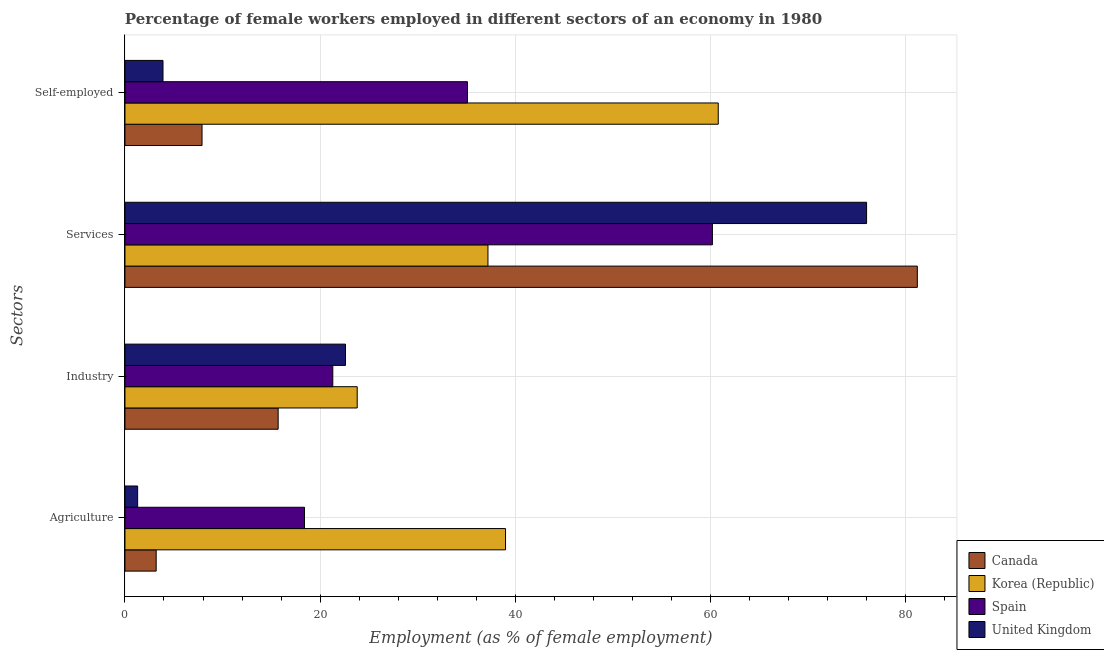How many different coloured bars are there?
Ensure brevity in your answer.  4. Are the number of bars on each tick of the Y-axis equal?
Provide a short and direct response. Yes. How many bars are there on the 3rd tick from the bottom?
Make the answer very short. 4. What is the label of the 3rd group of bars from the top?
Offer a very short reply. Industry. What is the percentage of female workers in industry in Spain?
Ensure brevity in your answer.  21.3. Across all countries, what is the maximum percentage of female workers in agriculture?
Offer a terse response. 39. Across all countries, what is the minimum percentage of female workers in services?
Provide a short and direct response. 37.2. In which country was the percentage of female workers in agriculture maximum?
Keep it short and to the point. Korea (Republic). In which country was the percentage of self employed female workers minimum?
Provide a short and direct response. United Kingdom. What is the total percentage of female workers in services in the graph?
Provide a succinct answer. 254.6. What is the difference between the percentage of female workers in industry in United Kingdom and that in Korea (Republic)?
Keep it short and to the point. -1.2. What is the difference between the percentage of female workers in services in Spain and the percentage of female workers in agriculture in Canada?
Your response must be concise. 57. What is the average percentage of female workers in industry per country?
Offer a very short reply. 20.85. What is the difference between the percentage of self employed female workers and percentage of female workers in industry in Spain?
Your answer should be very brief. 13.8. In how many countries, is the percentage of female workers in industry greater than 44 %?
Your response must be concise. 0. What is the ratio of the percentage of female workers in agriculture in Canada to that in Spain?
Provide a succinct answer. 0.17. Is the difference between the percentage of female workers in services in Korea (Republic) and Canada greater than the difference between the percentage of female workers in industry in Korea (Republic) and Canada?
Give a very brief answer. No. What is the difference between the highest and the second highest percentage of female workers in services?
Provide a short and direct response. 5.2. What is the difference between the highest and the lowest percentage of female workers in agriculture?
Your response must be concise. 37.7. In how many countries, is the percentage of female workers in services greater than the average percentage of female workers in services taken over all countries?
Offer a terse response. 2. What does the 4th bar from the top in Industry represents?
Your answer should be very brief. Canada. What does the 2nd bar from the bottom in Services represents?
Provide a short and direct response. Korea (Republic). How many bars are there?
Give a very brief answer. 16. Does the graph contain any zero values?
Your response must be concise. No. How many legend labels are there?
Provide a short and direct response. 4. What is the title of the graph?
Make the answer very short. Percentage of female workers employed in different sectors of an economy in 1980. What is the label or title of the X-axis?
Your answer should be compact. Employment (as % of female employment). What is the label or title of the Y-axis?
Your answer should be very brief. Sectors. What is the Employment (as % of female employment) of Canada in Agriculture?
Make the answer very short. 3.2. What is the Employment (as % of female employment) in Spain in Agriculture?
Provide a short and direct response. 18.4. What is the Employment (as % of female employment) of United Kingdom in Agriculture?
Ensure brevity in your answer.  1.3. What is the Employment (as % of female employment) in Canada in Industry?
Provide a short and direct response. 15.7. What is the Employment (as % of female employment) in Korea (Republic) in Industry?
Ensure brevity in your answer.  23.8. What is the Employment (as % of female employment) in Spain in Industry?
Keep it short and to the point. 21.3. What is the Employment (as % of female employment) in United Kingdom in Industry?
Make the answer very short. 22.6. What is the Employment (as % of female employment) of Canada in Services?
Give a very brief answer. 81.2. What is the Employment (as % of female employment) in Korea (Republic) in Services?
Provide a short and direct response. 37.2. What is the Employment (as % of female employment) in Spain in Services?
Offer a terse response. 60.2. What is the Employment (as % of female employment) of United Kingdom in Services?
Provide a succinct answer. 76. What is the Employment (as % of female employment) of Canada in Self-employed?
Offer a very short reply. 7.9. What is the Employment (as % of female employment) of Korea (Republic) in Self-employed?
Ensure brevity in your answer.  60.8. What is the Employment (as % of female employment) of Spain in Self-employed?
Make the answer very short. 35.1. What is the Employment (as % of female employment) in United Kingdom in Self-employed?
Provide a succinct answer. 3.9. Across all Sectors, what is the maximum Employment (as % of female employment) in Canada?
Your response must be concise. 81.2. Across all Sectors, what is the maximum Employment (as % of female employment) of Korea (Republic)?
Make the answer very short. 60.8. Across all Sectors, what is the maximum Employment (as % of female employment) of Spain?
Your answer should be very brief. 60.2. Across all Sectors, what is the maximum Employment (as % of female employment) in United Kingdom?
Your answer should be compact. 76. Across all Sectors, what is the minimum Employment (as % of female employment) of Canada?
Offer a terse response. 3.2. Across all Sectors, what is the minimum Employment (as % of female employment) in Korea (Republic)?
Your answer should be very brief. 23.8. Across all Sectors, what is the minimum Employment (as % of female employment) of Spain?
Give a very brief answer. 18.4. Across all Sectors, what is the minimum Employment (as % of female employment) of United Kingdom?
Your response must be concise. 1.3. What is the total Employment (as % of female employment) of Canada in the graph?
Ensure brevity in your answer.  108. What is the total Employment (as % of female employment) of Korea (Republic) in the graph?
Offer a very short reply. 160.8. What is the total Employment (as % of female employment) of Spain in the graph?
Your response must be concise. 135. What is the total Employment (as % of female employment) in United Kingdom in the graph?
Your answer should be compact. 103.8. What is the difference between the Employment (as % of female employment) in Canada in Agriculture and that in Industry?
Ensure brevity in your answer.  -12.5. What is the difference between the Employment (as % of female employment) of Spain in Agriculture and that in Industry?
Provide a succinct answer. -2.9. What is the difference between the Employment (as % of female employment) of United Kingdom in Agriculture and that in Industry?
Give a very brief answer. -21.3. What is the difference between the Employment (as % of female employment) in Canada in Agriculture and that in Services?
Give a very brief answer. -78. What is the difference between the Employment (as % of female employment) in Korea (Republic) in Agriculture and that in Services?
Offer a terse response. 1.8. What is the difference between the Employment (as % of female employment) in Spain in Agriculture and that in Services?
Make the answer very short. -41.8. What is the difference between the Employment (as % of female employment) in United Kingdom in Agriculture and that in Services?
Keep it short and to the point. -74.7. What is the difference between the Employment (as % of female employment) in Canada in Agriculture and that in Self-employed?
Your response must be concise. -4.7. What is the difference between the Employment (as % of female employment) of Korea (Republic) in Agriculture and that in Self-employed?
Your answer should be compact. -21.8. What is the difference between the Employment (as % of female employment) of Spain in Agriculture and that in Self-employed?
Provide a succinct answer. -16.7. What is the difference between the Employment (as % of female employment) in Canada in Industry and that in Services?
Offer a very short reply. -65.5. What is the difference between the Employment (as % of female employment) of Korea (Republic) in Industry and that in Services?
Make the answer very short. -13.4. What is the difference between the Employment (as % of female employment) of Spain in Industry and that in Services?
Provide a short and direct response. -38.9. What is the difference between the Employment (as % of female employment) in United Kingdom in Industry and that in Services?
Provide a succinct answer. -53.4. What is the difference between the Employment (as % of female employment) of Korea (Republic) in Industry and that in Self-employed?
Your response must be concise. -37. What is the difference between the Employment (as % of female employment) of Spain in Industry and that in Self-employed?
Provide a succinct answer. -13.8. What is the difference between the Employment (as % of female employment) of Canada in Services and that in Self-employed?
Your answer should be very brief. 73.3. What is the difference between the Employment (as % of female employment) of Korea (Republic) in Services and that in Self-employed?
Give a very brief answer. -23.6. What is the difference between the Employment (as % of female employment) in Spain in Services and that in Self-employed?
Your response must be concise. 25.1. What is the difference between the Employment (as % of female employment) in United Kingdom in Services and that in Self-employed?
Offer a very short reply. 72.1. What is the difference between the Employment (as % of female employment) of Canada in Agriculture and the Employment (as % of female employment) of Korea (Republic) in Industry?
Offer a very short reply. -20.6. What is the difference between the Employment (as % of female employment) in Canada in Agriculture and the Employment (as % of female employment) in Spain in Industry?
Provide a succinct answer. -18.1. What is the difference between the Employment (as % of female employment) of Canada in Agriculture and the Employment (as % of female employment) of United Kingdom in Industry?
Your response must be concise. -19.4. What is the difference between the Employment (as % of female employment) of Korea (Republic) in Agriculture and the Employment (as % of female employment) of United Kingdom in Industry?
Your response must be concise. 16.4. What is the difference between the Employment (as % of female employment) of Spain in Agriculture and the Employment (as % of female employment) of United Kingdom in Industry?
Make the answer very short. -4.2. What is the difference between the Employment (as % of female employment) in Canada in Agriculture and the Employment (as % of female employment) in Korea (Republic) in Services?
Give a very brief answer. -34. What is the difference between the Employment (as % of female employment) of Canada in Agriculture and the Employment (as % of female employment) of Spain in Services?
Offer a terse response. -57. What is the difference between the Employment (as % of female employment) of Canada in Agriculture and the Employment (as % of female employment) of United Kingdom in Services?
Your answer should be very brief. -72.8. What is the difference between the Employment (as % of female employment) of Korea (Republic) in Agriculture and the Employment (as % of female employment) of Spain in Services?
Ensure brevity in your answer.  -21.2. What is the difference between the Employment (as % of female employment) in Korea (Republic) in Agriculture and the Employment (as % of female employment) in United Kingdom in Services?
Offer a very short reply. -37. What is the difference between the Employment (as % of female employment) in Spain in Agriculture and the Employment (as % of female employment) in United Kingdom in Services?
Offer a terse response. -57.6. What is the difference between the Employment (as % of female employment) of Canada in Agriculture and the Employment (as % of female employment) of Korea (Republic) in Self-employed?
Your answer should be very brief. -57.6. What is the difference between the Employment (as % of female employment) in Canada in Agriculture and the Employment (as % of female employment) in Spain in Self-employed?
Offer a very short reply. -31.9. What is the difference between the Employment (as % of female employment) of Canada in Agriculture and the Employment (as % of female employment) of United Kingdom in Self-employed?
Provide a short and direct response. -0.7. What is the difference between the Employment (as % of female employment) in Korea (Republic) in Agriculture and the Employment (as % of female employment) in United Kingdom in Self-employed?
Your answer should be compact. 35.1. What is the difference between the Employment (as % of female employment) in Spain in Agriculture and the Employment (as % of female employment) in United Kingdom in Self-employed?
Offer a very short reply. 14.5. What is the difference between the Employment (as % of female employment) of Canada in Industry and the Employment (as % of female employment) of Korea (Republic) in Services?
Your answer should be compact. -21.5. What is the difference between the Employment (as % of female employment) of Canada in Industry and the Employment (as % of female employment) of Spain in Services?
Make the answer very short. -44.5. What is the difference between the Employment (as % of female employment) of Canada in Industry and the Employment (as % of female employment) of United Kingdom in Services?
Provide a succinct answer. -60.3. What is the difference between the Employment (as % of female employment) of Korea (Republic) in Industry and the Employment (as % of female employment) of Spain in Services?
Offer a very short reply. -36.4. What is the difference between the Employment (as % of female employment) in Korea (Republic) in Industry and the Employment (as % of female employment) in United Kingdom in Services?
Offer a terse response. -52.2. What is the difference between the Employment (as % of female employment) of Spain in Industry and the Employment (as % of female employment) of United Kingdom in Services?
Your answer should be compact. -54.7. What is the difference between the Employment (as % of female employment) of Canada in Industry and the Employment (as % of female employment) of Korea (Republic) in Self-employed?
Your answer should be compact. -45.1. What is the difference between the Employment (as % of female employment) of Canada in Industry and the Employment (as % of female employment) of Spain in Self-employed?
Your answer should be compact. -19.4. What is the difference between the Employment (as % of female employment) in Korea (Republic) in Industry and the Employment (as % of female employment) in Spain in Self-employed?
Give a very brief answer. -11.3. What is the difference between the Employment (as % of female employment) of Canada in Services and the Employment (as % of female employment) of Korea (Republic) in Self-employed?
Provide a succinct answer. 20.4. What is the difference between the Employment (as % of female employment) of Canada in Services and the Employment (as % of female employment) of Spain in Self-employed?
Make the answer very short. 46.1. What is the difference between the Employment (as % of female employment) in Canada in Services and the Employment (as % of female employment) in United Kingdom in Self-employed?
Ensure brevity in your answer.  77.3. What is the difference between the Employment (as % of female employment) of Korea (Republic) in Services and the Employment (as % of female employment) of United Kingdom in Self-employed?
Give a very brief answer. 33.3. What is the difference between the Employment (as % of female employment) of Spain in Services and the Employment (as % of female employment) of United Kingdom in Self-employed?
Your response must be concise. 56.3. What is the average Employment (as % of female employment) of Korea (Republic) per Sectors?
Offer a very short reply. 40.2. What is the average Employment (as % of female employment) in Spain per Sectors?
Give a very brief answer. 33.75. What is the average Employment (as % of female employment) in United Kingdom per Sectors?
Your response must be concise. 25.95. What is the difference between the Employment (as % of female employment) in Canada and Employment (as % of female employment) in Korea (Republic) in Agriculture?
Provide a succinct answer. -35.8. What is the difference between the Employment (as % of female employment) of Canada and Employment (as % of female employment) of Spain in Agriculture?
Provide a short and direct response. -15.2. What is the difference between the Employment (as % of female employment) of Canada and Employment (as % of female employment) of United Kingdom in Agriculture?
Provide a succinct answer. 1.9. What is the difference between the Employment (as % of female employment) of Korea (Republic) and Employment (as % of female employment) of Spain in Agriculture?
Offer a very short reply. 20.6. What is the difference between the Employment (as % of female employment) in Korea (Republic) and Employment (as % of female employment) in United Kingdom in Agriculture?
Offer a terse response. 37.7. What is the difference between the Employment (as % of female employment) in Canada and Employment (as % of female employment) in Spain in Industry?
Make the answer very short. -5.6. What is the difference between the Employment (as % of female employment) of Canada and Employment (as % of female employment) of United Kingdom in Industry?
Give a very brief answer. -6.9. What is the difference between the Employment (as % of female employment) of Canada and Employment (as % of female employment) of United Kingdom in Services?
Your answer should be very brief. 5.2. What is the difference between the Employment (as % of female employment) of Korea (Republic) and Employment (as % of female employment) of United Kingdom in Services?
Give a very brief answer. -38.8. What is the difference between the Employment (as % of female employment) of Spain and Employment (as % of female employment) of United Kingdom in Services?
Offer a very short reply. -15.8. What is the difference between the Employment (as % of female employment) of Canada and Employment (as % of female employment) of Korea (Republic) in Self-employed?
Your answer should be compact. -52.9. What is the difference between the Employment (as % of female employment) of Canada and Employment (as % of female employment) of Spain in Self-employed?
Your answer should be very brief. -27.2. What is the difference between the Employment (as % of female employment) in Canada and Employment (as % of female employment) in United Kingdom in Self-employed?
Give a very brief answer. 4. What is the difference between the Employment (as % of female employment) of Korea (Republic) and Employment (as % of female employment) of Spain in Self-employed?
Your answer should be very brief. 25.7. What is the difference between the Employment (as % of female employment) of Korea (Republic) and Employment (as % of female employment) of United Kingdom in Self-employed?
Offer a very short reply. 56.9. What is the difference between the Employment (as % of female employment) in Spain and Employment (as % of female employment) in United Kingdom in Self-employed?
Your answer should be very brief. 31.2. What is the ratio of the Employment (as % of female employment) in Canada in Agriculture to that in Industry?
Provide a short and direct response. 0.2. What is the ratio of the Employment (as % of female employment) of Korea (Republic) in Agriculture to that in Industry?
Your response must be concise. 1.64. What is the ratio of the Employment (as % of female employment) of Spain in Agriculture to that in Industry?
Your answer should be very brief. 0.86. What is the ratio of the Employment (as % of female employment) of United Kingdom in Agriculture to that in Industry?
Give a very brief answer. 0.06. What is the ratio of the Employment (as % of female employment) of Canada in Agriculture to that in Services?
Make the answer very short. 0.04. What is the ratio of the Employment (as % of female employment) in Korea (Republic) in Agriculture to that in Services?
Offer a terse response. 1.05. What is the ratio of the Employment (as % of female employment) in Spain in Agriculture to that in Services?
Your response must be concise. 0.31. What is the ratio of the Employment (as % of female employment) in United Kingdom in Agriculture to that in Services?
Provide a succinct answer. 0.02. What is the ratio of the Employment (as % of female employment) in Canada in Agriculture to that in Self-employed?
Provide a succinct answer. 0.41. What is the ratio of the Employment (as % of female employment) in Korea (Republic) in Agriculture to that in Self-employed?
Provide a succinct answer. 0.64. What is the ratio of the Employment (as % of female employment) of Spain in Agriculture to that in Self-employed?
Offer a terse response. 0.52. What is the ratio of the Employment (as % of female employment) of United Kingdom in Agriculture to that in Self-employed?
Your answer should be compact. 0.33. What is the ratio of the Employment (as % of female employment) in Canada in Industry to that in Services?
Ensure brevity in your answer.  0.19. What is the ratio of the Employment (as % of female employment) in Korea (Republic) in Industry to that in Services?
Provide a succinct answer. 0.64. What is the ratio of the Employment (as % of female employment) in Spain in Industry to that in Services?
Ensure brevity in your answer.  0.35. What is the ratio of the Employment (as % of female employment) of United Kingdom in Industry to that in Services?
Keep it short and to the point. 0.3. What is the ratio of the Employment (as % of female employment) in Canada in Industry to that in Self-employed?
Your answer should be compact. 1.99. What is the ratio of the Employment (as % of female employment) in Korea (Republic) in Industry to that in Self-employed?
Your answer should be compact. 0.39. What is the ratio of the Employment (as % of female employment) in Spain in Industry to that in Self-employed?
Offer a very short reply. 0.61. What is the ratio of the Employment (as % of female employment) of United Kingdom in Industry to that in Self-employed?
Your answer should be very brief. 5.79. What is the ratio of the Employment (as % of female employment) in Canada in Services to that in Self-employed?
Your response must be concise. 10.28. What is the ratio of the Employment (as % of female employment) of Korea (Republic) in Services to that in Self-employed?
Your response must be concise. 0.61. What is the ratio of the Employment (as % of female employment) of Spain in Services to that in Self-employed?
Your response must be concise. 1.72. What is the ratio of the Employment (as % of female employment) of United Kingdom in Services to that in Self-employed?
Give a very brief answer. 19.49. What is the difference between the highest and the second highest Employment (as % of female employment) of Canada?
Keep it short and to the point. 65.5. What is the difference between the highest and the second highest Employment (as % of female employment) of Korea (Republic)?
Your answer should be very brief. 21.8. What is the difference between the highest and the second highest Employment (as % of female employment) of Spain?
Keep it short and to the point. 25.1. What is the difference between the highest and the second highest Employment (as % of female employment) of United Kingdom?
Give a very brief answer. 53.4. What is the difference between the highest and the lowest Employment (as % of female employment) of Canada?
Offer a very short reply. 78. What is the difference between the highest and the lowest Employment (as % of female employment) in Spain?
Give a very brief answer. 41.8. What is the difference between the highest and the lowest Employment (as % of female employment) in United Kingdom?
Provide a succinct answer. 74.7. 